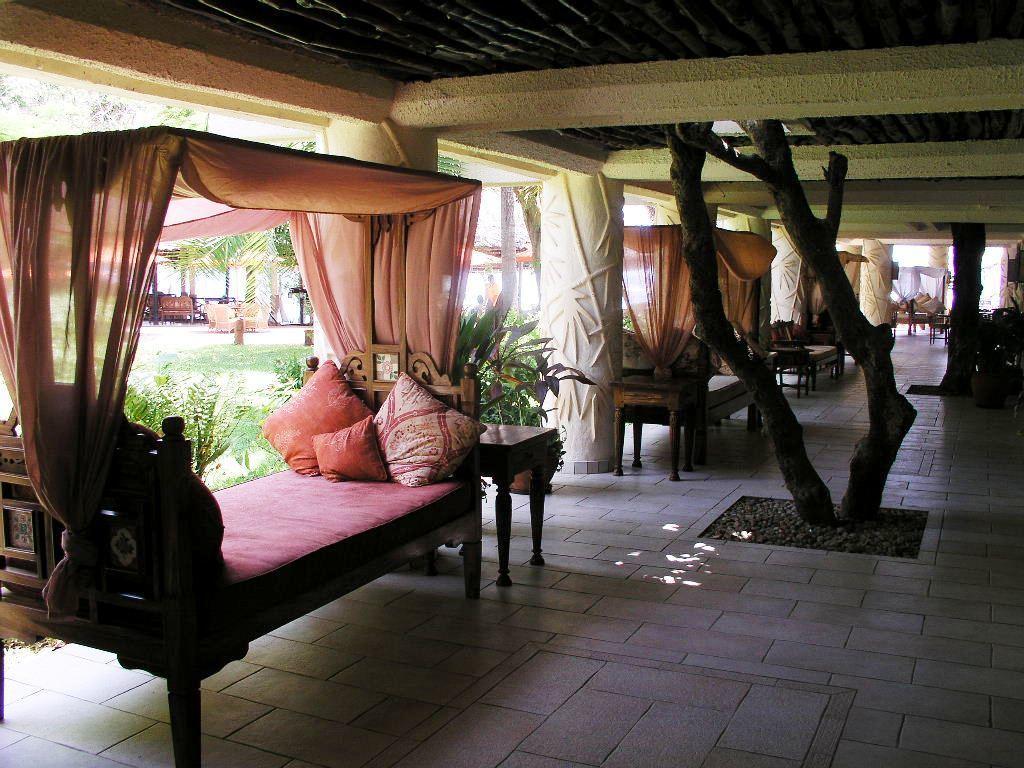Please provide a concise description of this image. This picture shows a bed with some pillows on it. There is some curtains all over the bed. In the background there is a pillar, plants and some other beds here. There is a tree in the middle. We can observe some benches and open grass here 